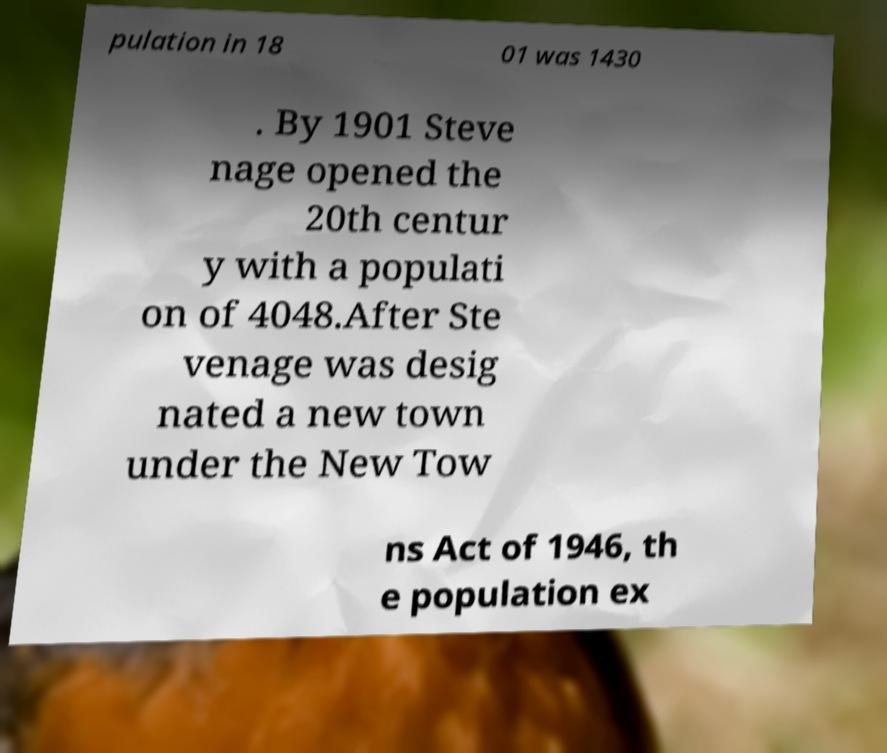Can you read and provide the text displayed in the image?This photo seems to have some interesting text. Can you extract and type it out for me? pulation in 18 01 was 1430 . By 1901 Steve nage opened the 20th centur y with a populati on of 4048.After Ste venage was desig nated a new town under the New Tow ns Act of 1946, th e population ex 